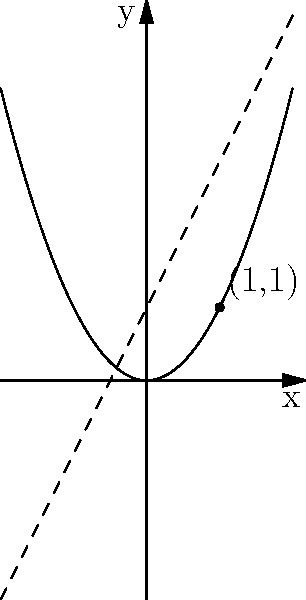Given the parabola $y = x^2$ and the point (1,1) on the curve, find the equation of the tangent line to the parabola at this point. To find the equation of the tangent line to the parabola $y = x^2$ at the point (1,1), we'll follow these steps:

1) The general equation of a tangent line is $y - y_1 = m(x - x_1)$, where $(x_1, y_1)$ is the point of tangency and $m$ is the slope of the tangent line.

2) We know the point of tangency is (1,1), so $x_1 = 1$ and $y_1 = 1$.

3) To find the slope $m$, we need to use the derivative of the function $f(x) = x^2$ at $x = 1$:

   $f'(x) = 2x$
   $f'(1) = 2(1) = 2$

4) So, the slope of the tangent line at (1,1) is 2.

5) Now we can substitute these values into the general equation of a tangent line:

   $y - 1 = 2(x - 1)$

6) Simplify by distributing the 2:

   $y - 1 = 2x - 2$

7) Add 1 to both sides to isolate $y$:

   $y = 2x - 1$

This is the equation of the tangent line to the parabola $y = x^2$ at the point (1,1).
Answer: $y = 2x - 1$ 